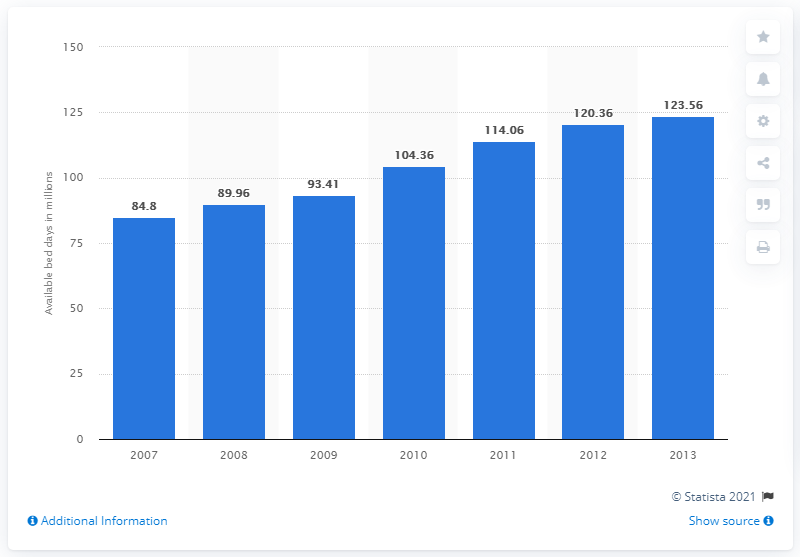Draw attention to some important aspects in this diagram. In 2013, there were 123.56 bed days in the North American cruise industry. 